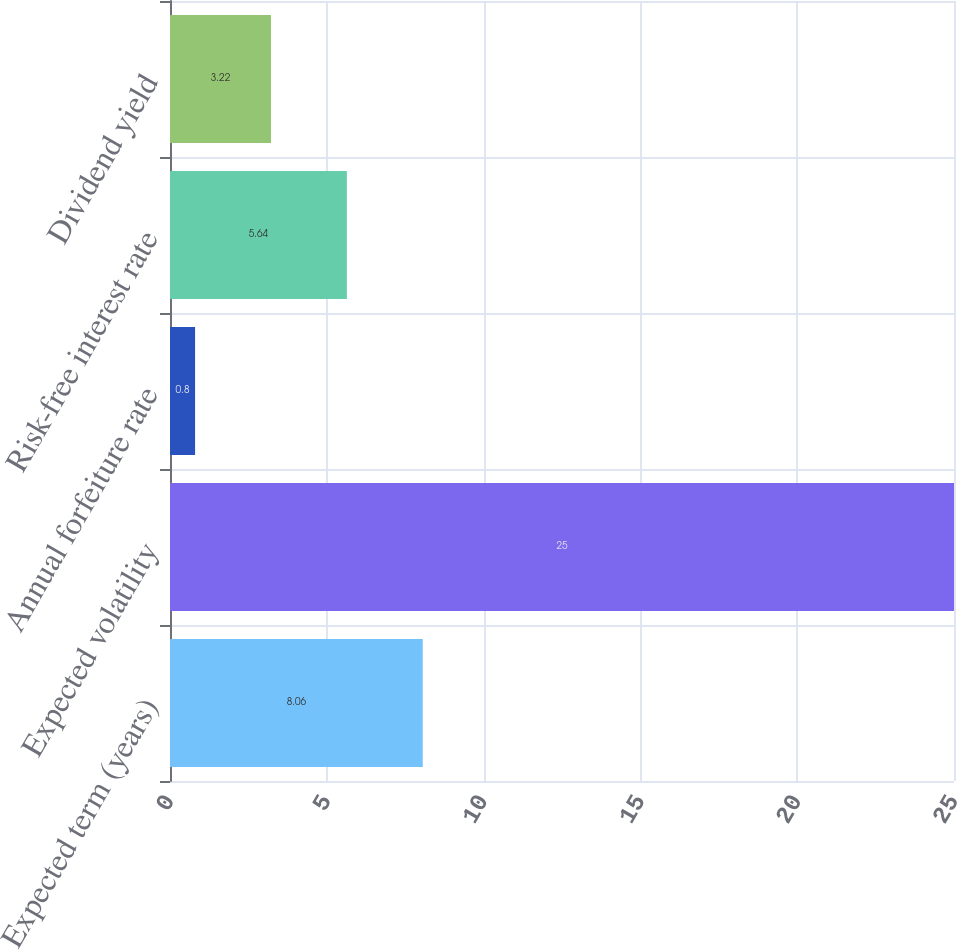Convert chart to OTSL. <chart><loc_0><loc_0><loc_500><loc_500><bar_chart><fcel>Expected term (years)<fcel>Expected volatility<fcel>Annual forfeiture rate<fcel>Risk-free interest rate<fcel>Dividend yield<nl><fcel>8.06<fcel>25<fcel>0.8<fcel>5.64<fcel>3.22<nl></chart> 